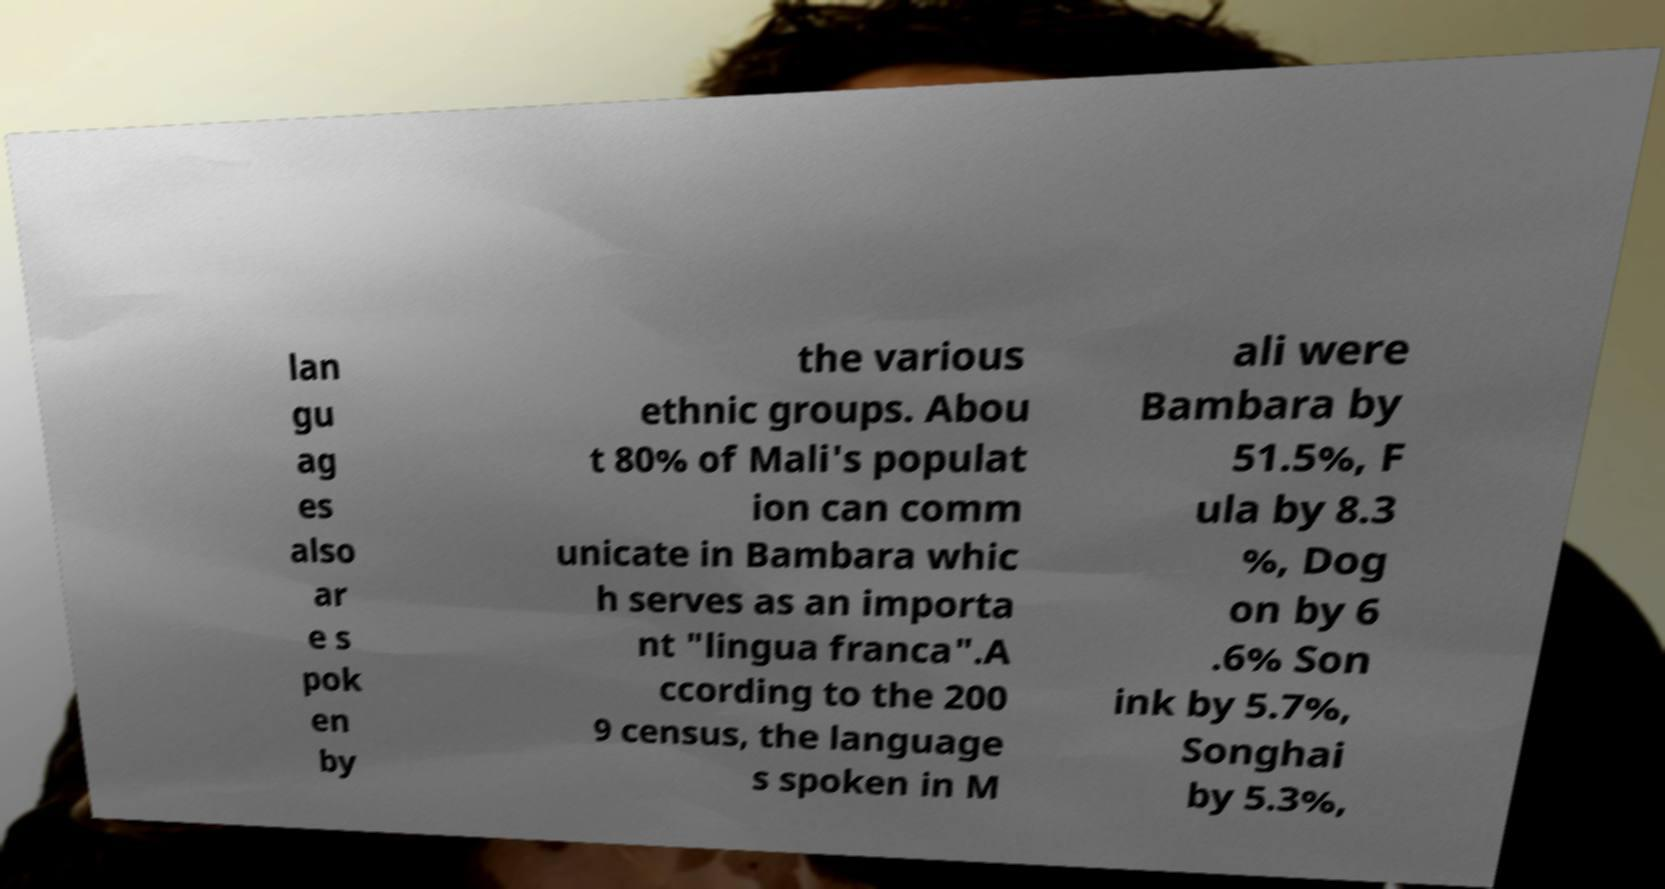Could you assist in decoding the text presented in this image and type it out clearly? lan gu ag es also ar e s pok en by the various ethnic groups. Abou t 80% of Mali's populat ion can comm unicate in Bambara whic h serves as an importa nt "lingua franca".A ccording to the 200 9 census, the language s spoken in M ali were Bambara by 51.5%, F ula by 8.3 %, Dog on by 6 .6% Son ink by 5.7%, Songhai by 5.3%, 